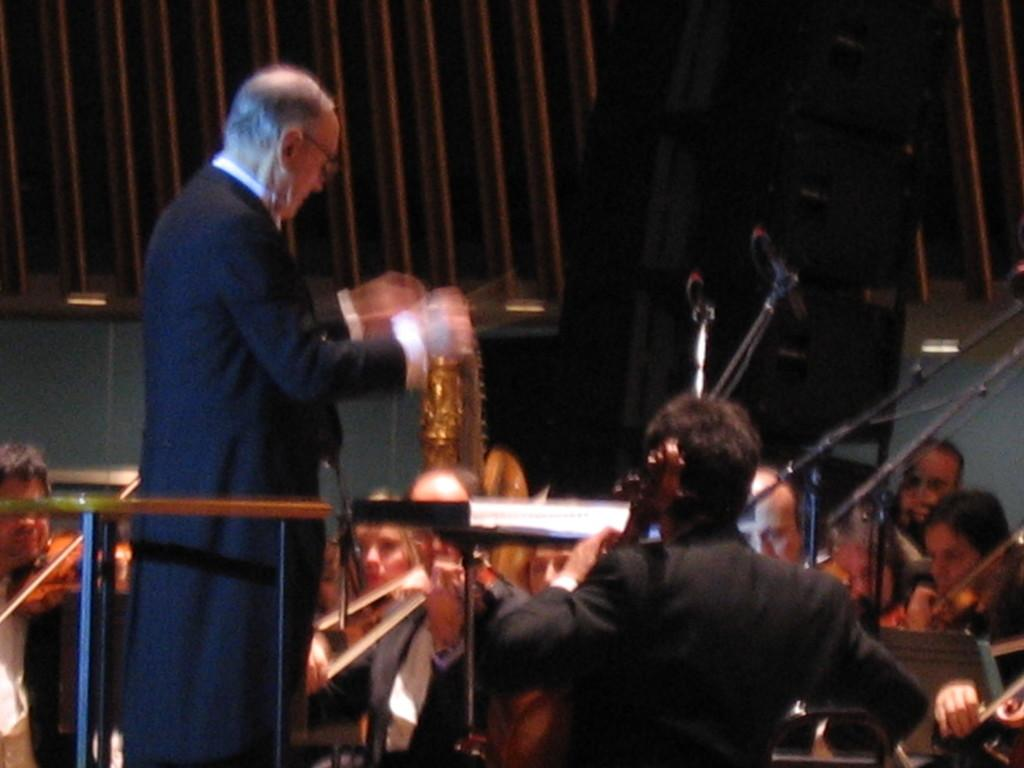How many people are in the image? There are people in the image, but the exact number is not specified. What are the people doing in the image? Some people are sitting, and one is standing. What are the people wearing in the image? The people are wearing clothes. What objects are visible in the image that are related to sound? A: There are microphones visible in the image. What objects are visible in the image that are related to music? There are musical instruments in the image. What is the condition of the owner of the musical instruments in the image? There is no information about the owner of the musical instruments in the image, so we cannot determine their condition. What small detail can be seen on the clothing of the people in the image? The facts provided do not mention any specific details about the clothing, so we cannot answer this question. 